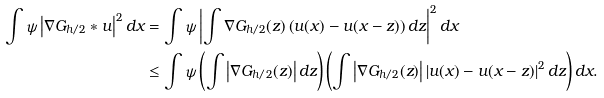Convert formula to latex. <formula><loc_0><loc_0><loc_500><loc_500>\int \psi \left | \nabla G _ { h / 2 } \ast u \right | ^ { 2 } d x & = \int \psi \left | \int \nabla G _ { h / 2 } ( z ) \left ( u ( x ) - u ( x - z ) \right ) d z \right | ^ { 2 } d x \\ & \leq \int \psi \left ( \int \left | \nabla G _ { h / 2 } ( z ) \right | d z \right ) \left ( \int \left | \nabla G _ { h / 2 } ( z ) \right | \left | u ( x ) - u ( x - z ) \right | ^ { 2 } d z \right ) d x .</formula> 